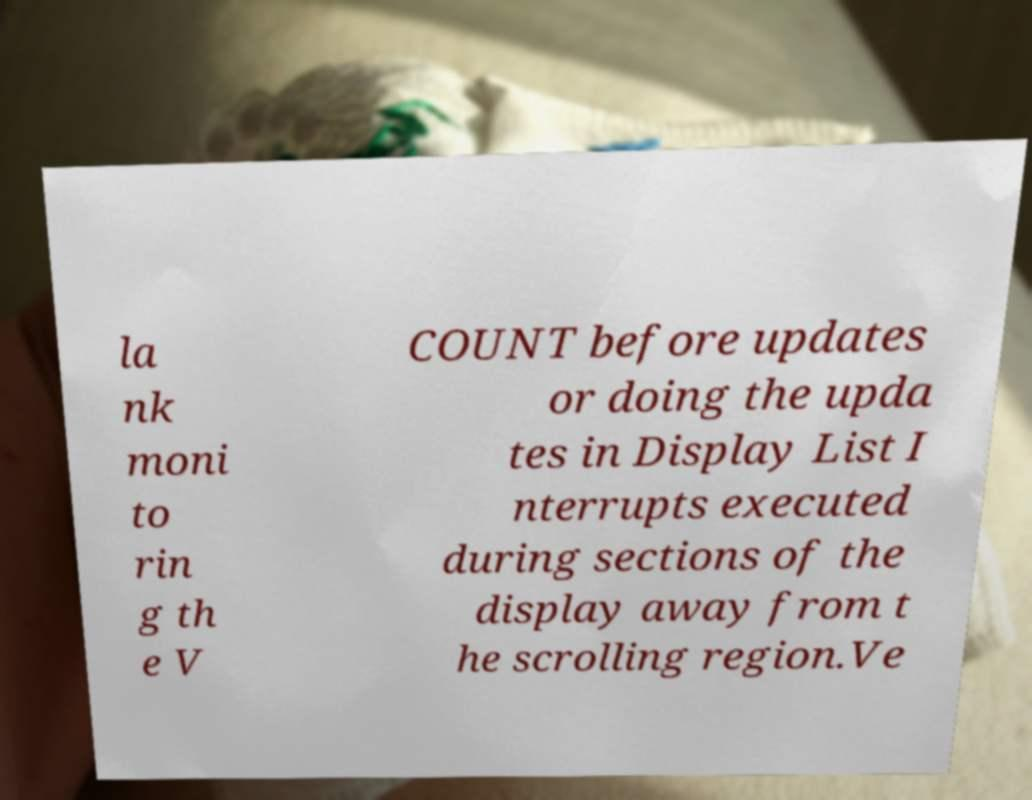Could you assist in decoding the text presented in this image and type it out clearly? la nk moni to rin g th e V COUNT before updates or doing the upda tes in Display List I nterrupts executed during sections of the display away from t he scrolling region.Ve 